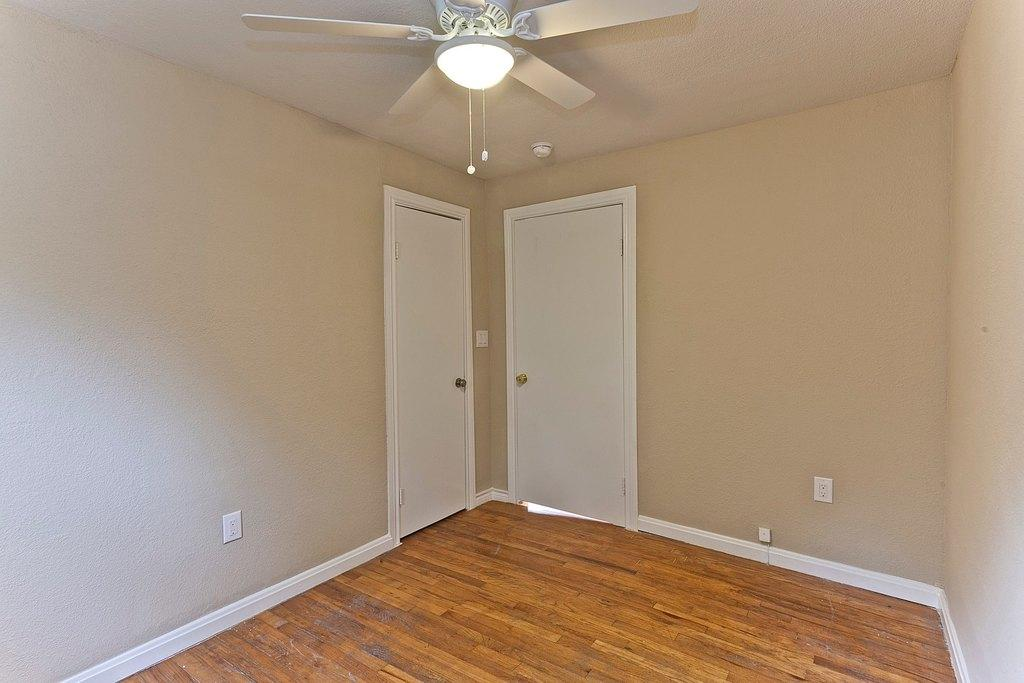What type of space is depicted in the image? The image is of a room. What color is the floor in the room? The floor in the room is brown in color. How many doors are present in the room? There are two white doors in the room. What surrounds the room? The room has walls. What is located at the top of the room? There is a ceiling fan at the top of the room. What type of cannon is present in the room? There is no cannon present in the room; the image only shows a room with a brown floor, two white doors, walls, and a ceiling fan. What game is being played in the room? There is no game being played in the room; the image only shows a room with a brown floor, two white doors, walls, and a ceiling fan. 